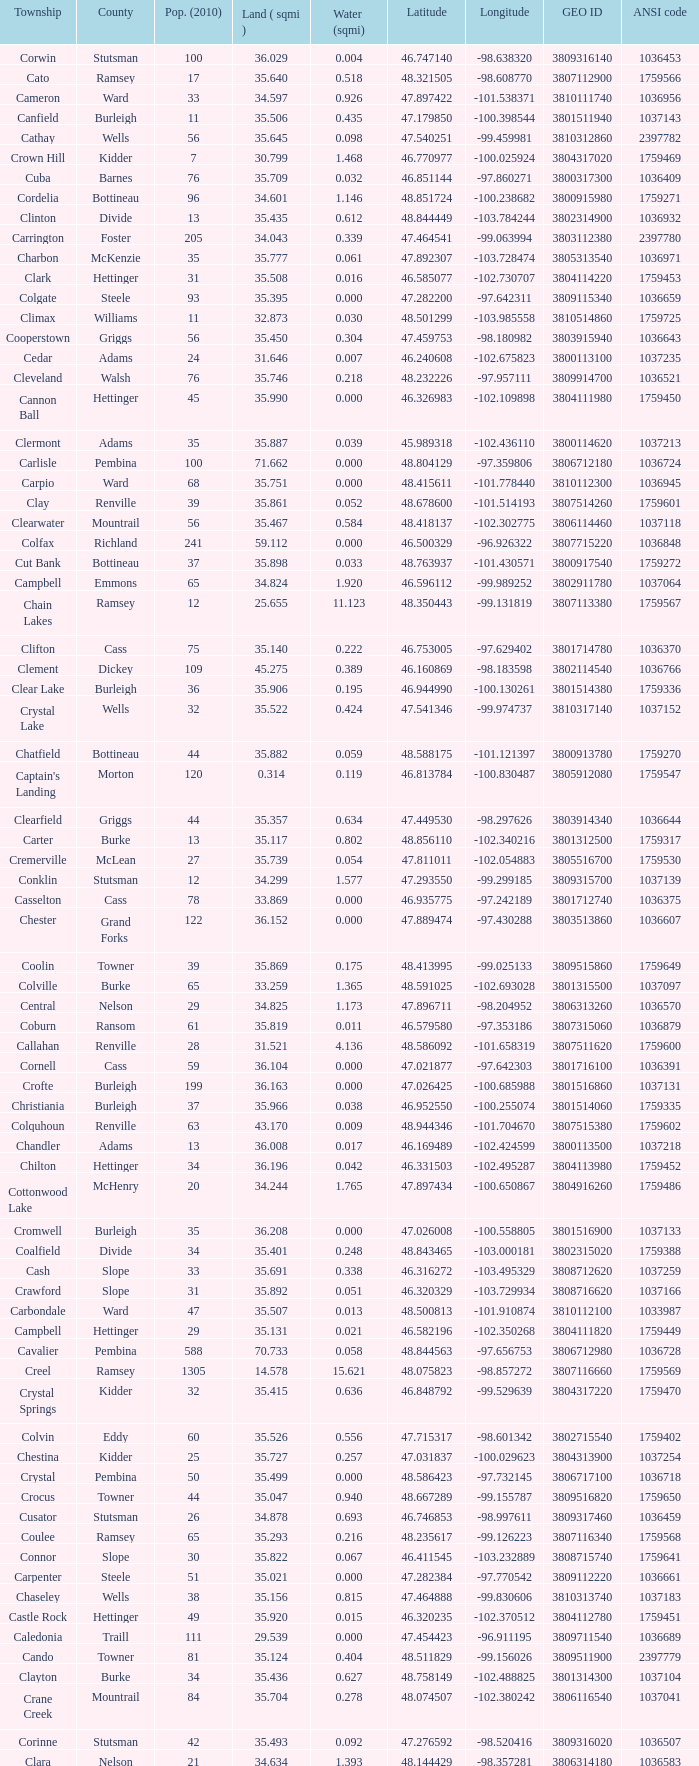What was the latitude of the Clearwater townsship? 48.418137. 